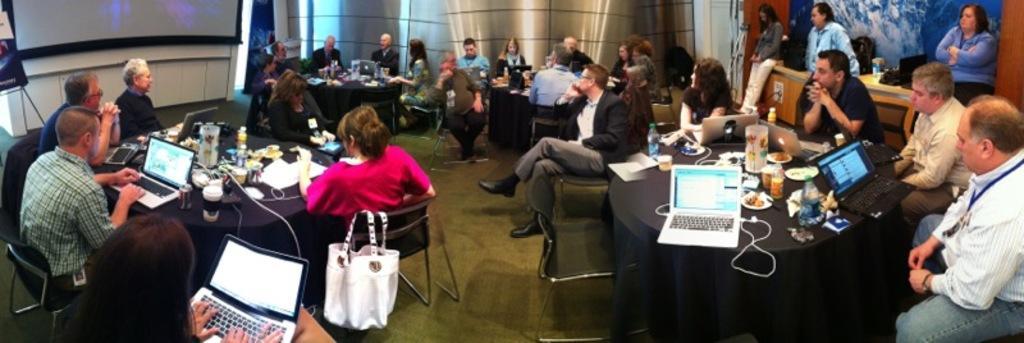In one or two sentences, can you explain what this image depicts? Here we can see groups of people sitting on chairs with table in front of them having laptops and Bottles And papers present on it and in the middle we can see a handbag on the chair and on the right side we can see some people standing here and there 